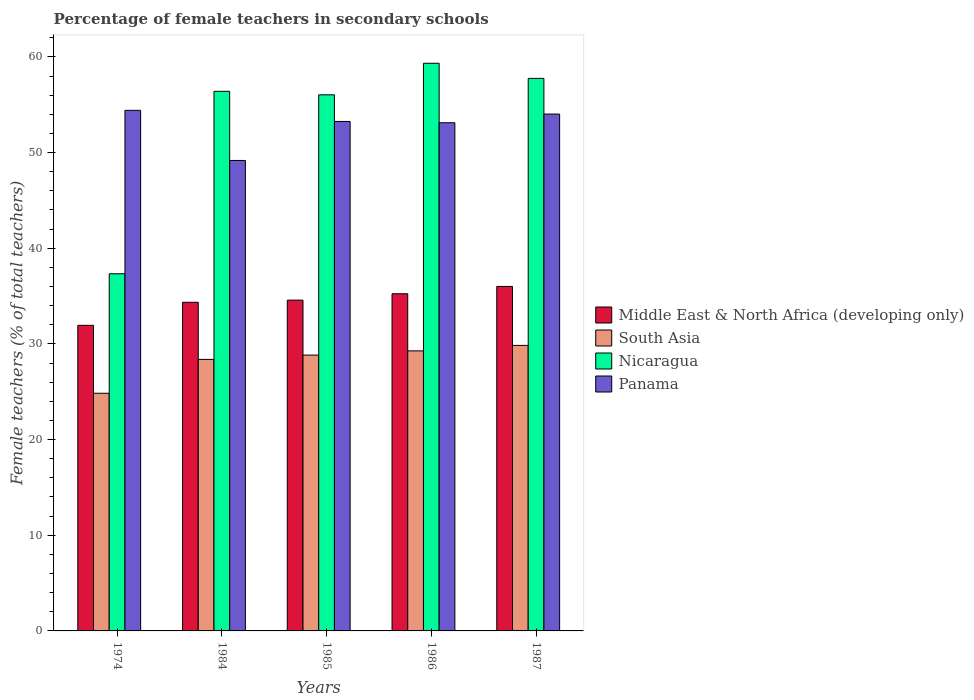How many groups of bars are there?
Provide a short and direct response. 5. Are the number of bars per tick equal to the number of legend labels?
Your answer should be compact. Yes. Are the number of bars on each tick of the X-axis equal?
Your answer should be very brief. Yes. How many bars are there on the 2nd tick from the right?
Your answer should be compact. 4. What is the label of the 1st group of bars from the left?
Provide a short and direct response. 1974. In how many cases, is the number of bars for a given year not equal to the number of legend labels?
Offer a very short reply. 0. What is the percentage of female teachers in Nicaragua in 1984?
Offer a terse response. 56.4. Across all years, what is the maximum percentage of female teachers in South Asia?
Offer a terse response. 29.84. Across all years, what is the minimum percentage of female teachers in Nicaragua?
Provide a succinct answer. 37.33. In which year was the percentage of female teachers in South Asia maximum?
Your response must be concise. 1987. In which year was the percentage of female teachers in Nicaragua minimum?
Provide a succinct answer. 1974. What is the total percentage of female teachers in Panama in the graph?
Offer a terse response. 263.97. What is the difference between the percentage of female teachers in South Asia in 1984 and that in 1986?
Give a very brief answer. -0.89. What is the difference between the percentage of female teachers in South Asia in 1986 and the percentage of female teachers in Middle East & North Africa (developing only) in 1985?
Your answer should be compact. -5.3. What is the average percentage of female teachers in South Asia per year?
Provide a succinct answer. 28.23. In the year 1987, what is the difference between the percentage of female teachers in Panama and percentage of female teachers in Nicaragua?
Give a very brief answer. -3.73. In how many years, is the percentage of female teachers in Panama greater than 44 %?
Your answer should be very brief. 5. What is the ratio of the percentage of female teachers in Nicaragua in 1974 to that in 1985?
Make the answer very short. 0.67. Is the percentage of female teachers in Middle East & North Africa (developing only) in 1974 less than that in 1984?
Make the answer very short. Yes. Is the difference between the percentage of female teachers in Panama in 1985 and 1987 greater than the difference between the percentage of female teachers in Nicaragua in 1985 and 1987?
Your response must be concise. Yes. What is the difference between the highest and the second highest percentage of female teachers in Nicaragua?
Ensure brevity in your answer.  1.58. What is the difference between the highest and the lowest percentage of female teachers in Panama?
Offer a terse response. 5.24. In how many years, is the percentage of female teachers in Panama greater than the average percentage of female teachers in Panama taken over all years?
Ensure brevity in your answer.  4. Is the sum of the percentage of female teachers in Nicaragua in 1974 and 1984 greater than the maximum percentage of female teachers in South Asia across all years?
Offer a very short reply. Yes. What does the 1st bar from the left in 1987 represents?
Your answer should be compact. Middle East & North Africa (developing only). What does the 3rd bar from the right in 1985 represents?
Your answer should be compact. South Asia. How many bars are there?
Your answer should be very brief. 20. Does the graph contain grids?
Provide a short and direct response. No. How many legend labels are there?
Provide a succinct answer. 4. How are the legend labels stacked?
Offer a very short reply. Vertical. What is the title of the graph?
Provide a succinct answer. Percentage of female teachers in secondary schools. Does "Uzbekistan" appear as one of the legend labels in the graph?
Make the answer very short. No. What is the label or title of the X-axis?
Provide a succinct answer. Years. What is the label or title of the Y-axis?
Give a very brief answer. Female teachers (% of total teachers). What is the Female teachers (% of total teachers) in Middle East & North Africa (developing only) in 1974?
Your answer should be compact. 31.94. What is the Female teachers (% of total teachers) in South Asia in 1974?
Keep it short and to the point. 24.84. What is the Female teachers (% of total teachers) of Nicaragua in 1974?
Your response must be concise. 37.33. What is the Female teachers (% of total teachers) in Panama in 1974?
Provide a short and direct response. 54.41. What is the Female teachers (% of total teachers) in Middle East & North Africa (developing only) in 1984?
Your answer should be compact. 34.35. What is the Female teachers (% of total teachers) in South Asia in 1984?
Provide a succinct answer. 28.38. What is the Female teachers (% of total teachers) of Nicaragua in 1984?
Offer a very short reply. 56.4. What is the Female teachers (% of total teachers) in Panama in 1984?
Your answer should be compact. 49.17. What is the Female teachers (% of total teachers) in Middle East & North Africa (developing only) in 1985?
Provide a short and direct response. 34.57. What is the Female teachers (% of total teachers) in South Asia in 1985?
Your answer should be very brief. 28.83. What is the Female teachers (% of total teachers) in Nicaragua in 1985?
Provide a short and direct response. 56.03. What is the Female teachers (% of total teachers) in Panama in 1985?
Your answer should be compact. 53.25. What is the Female teachers (% of total teachers) in Middle East & North Africa (developing only) in 1986?
Offer a very short reply. 35.24. What is the Female teachers (% of total teachers) of South Asia in 1986?
Offer a terse response. 29.27. What is the Female teachers (% of total teachers) in Nicaragua in 1986?
Give a very brief answer. 59.33. What is the Female teachers (% of total teachers) in Panama in 1986?
Your answer should be very brief. 53.11. What is the Female teachers (% of total teachers) in Middle East & North Africa (developing only) in 1987?
Your response must be concise. 36.01. What is the Female teachers (% of total teachers) in South Asia in 1987?
Provide a short and direct response. 29.84. What is the Female teachers (% of total teachers) in Nicaragua in 1987?
Your response must be concise. 57.75. What is the Female teachers (% of total teachers) of Panama in 1987?
Keep it short and to the point. 54.02. Across all years, what is the maximum Female teachers (% of total teachers) in Middle East & North Africa (developing only)?
Your response must be concise. 36.01. Across all years, what is the maximum Female teachers (% of total teachers) of South Asia?
Make the answer very short. 29.84. Across all years, what is the maximum Female teachers (% of total teachers) in Nicaragua?
Make the answer very short. 59.33. Across all years, what is the maximum Female teachers (% of total teachers) of Panama?
Give a very brief answer. 54.41. Across all years, what is the minimum Female teachers (% of total teachers) of Middle East & North Africa (developing only)?
Your response must be concise. 31.94. Across all years, what is the minimum Female teachers (% of total teachers) of South Asia?
Ensure brevity in your answer.  24.84. Across all years, what is the minimum Female teachers (% of total teachers) of Nicaragua?
Ensure brevity in your answer.  37.33. Across all years, what is the minimum Female teachers (% of total teachers) of Panama?
Provide a short and direct response. 49.17. What is the total Female teachers (% of total teachers) of Middle East & North Africa (developing only) in the graph?
Keep it short and to the point. 172.11. What is the total Female teachers (% of total teachers) in South Asia in the graph?
Provide a short and direct response. 141.16. What is the total Female teachers (% of total teachers) in Nicaragua in the graph?
Keep it short and to the point. 266.85. What is the total Female teachers (% of total teachers) of Panama in the graph?
Your answer should be compact. 263.97. What is the difference between the Female teachers (% of total teachers) of Middle East & North Africa (developing only) in 1974 and that in 1984?
Keep it short and to the point. -2.41. What is the difference between the Female teachers (% of total teachers) of South Asia in 1974 and that in 1984?
Make the answer very short. -3.54. What is the difference between the Female teachers (% of total teachers) of Nicaragua in 1974 and that in 1984?
Provide a short and direct response. -19.07. What is the difference between the Female teachers (% of total teachers) in Panama in 1974 and that in 1984?
Your response must be concise. 5.24. What is the difference between the Female teachers (% of total teachers) in Middle East & North Africa (developing only) in 1974 and that in 1985?
Offer a terse response. -2.63. What is the difference between the Female teachers (% of total teachers) in South Asia in 1974 and that in 1985?
Your answer should be compact. -3.99. What is the difference between the Female teachers (% of total teachers) in Nicaragua in 1974 and that in 1985?
Ensure brevity in your answer.  -18.7. What is the difference between the Female teachers (% of total teachers) of Panama in 1974 and that in 1985?
Your answer should be very brief. 1.16. What is the difference between the Female teachers (% of total teachers) in Middle East & North Africa (developing only) in 1974 and that in 1986?
Provide a succinct answer. -3.3. What is the difference between the Female teachers (% of total teachers) in South Asia in 1974 and that in 1986?
Your response must be concise. -4.43. What is the difference between the Female teachers (% of total teachers) in Nicaragua in 1974 and that in 1986?
Provide a succinct answer. -22. What is the difference between the Female teachers (% of total teachers) of Panama in 1974 and that in 1986?
Provide a succinct answer. 1.3. What is the difference between the Female teachers (% of total teachers) in Middle East & North Africa (developing only) in 1974 and that in 1987?
Provide a short and direct response. -4.07. What is the difference between the Female teachers (% of total teachers) of South Asia in 1974 and that in 1987?
Keep it short and to the point. -5. What is the difference between the Female teachers (% of total teachers) of Nicaragua in 1974 and that in 1987?
Give a very brief answer. -20.42. What is the difference between the Female teachers (% of total teachers) of Panama in 1974 and that in 1987?
Make the answer very short. 0.39. What is the difference between the Female teachers (% of total teachers) in Middle East & North Africa (developing only) in 1984 and that in 1985?
Provide a succinct answer. -0.23. What is the difference between the Female teachers (% of total teachers) of South Asia in 1984 and that in 1985?
Ensure brevity in your answer.  -0.45. What is the difference between the Female teachers (% of total teachers) in Nicaragua in 1984 and that in 1985?
Provide a succinct answer. 0.37. What is the difference between the Female teachers (% of total teachers) in Panama in 1984 and that in 1985?
Give a very brief answer. -4.08. What is the difference between the Female teachers (% of total teachers) of Middle East & North Africa (developing only) in 1984 and that in 1986?
Provide a short and direct response. -0.89. What is the difference between the Female teachers (% of total teachers) in South Asia in 1984 and that in 1986?
Your answer should be compact. -0.89. What is the difference between the Female teachers (% of total teachers) of Nicaragua in 1984 and that in 1986?
Ensure brevity in your answer.  -2.93. What is the difference between the Female teachers (% of total teachers) of Panama in 1984 and that in 1986?
Give a very brief answer. -3.94. What is the difference between the Female teachers (% of total teachers) of Middle East & North Africa (developing only) in 1984 and that in 1987?
Provide a short and direct response. -1.66. What is the difference between the Female teachers (% of total teachers) of South Asia in 1984 and that in 1987?
Make the answer very short. -1.46. What is the difference between the Female teachers (% of total teachers) of Nicaragua in 1984 and that in 1987?
Ensure brevity in your answer.  -1.35. What is the difference between the Female teachers (% of total teachers) in Panama in 1984 and that in 1987?
Your response must be concise. -4.85. What is the difference between the Female teachers (% of total teachers) in Middle East & North Africa (developing only) in 1985 and that in 1986?
Offer a terse response. -0.67. What is the difference between the Female teachers (% of total teachers) of South Asia in 1985 and that in 1986?
Give a very brief answer. -0.44. What is the difference between the Female teachers (% of total teachers) in Nicaragua in 1985 and that in 1986?
Offer a very short reply. -3.3. What is the difference between the Female teachers (% of total teachers) of Panama in 1985 and that in 1986?
Offer a very short reply. 0.13. What is the difference between the Female teachers (% of total teachers) in Middle East & North Africa (developing only) in 1985 and that in 1987?
Keep it short and to the point. -1.43. What is the difference between the Female teachers (% of total teachers) of South Asia in 1985 and that in 1987?
Give a very brief answer. -1.01. What is the difference between the Female teachers (% of total teachers) of Nicaragua in 1985 and that in 1987?
Provide a short and direct response. -1.72. What is the difference between the Female teachers (% of total teachers) in Panama in 1985 and that in 1987?
Give a very brief answer. -0.77. What is the difference between the Female teachers (% of total teachers) of Middle East & North Africa (developing only) in 1986 and that in 1987?
Your answer should be very brief. -0.76. What is the difference between the Female teachers (% of total teachers) in South Asia in 1986 and that in 1987?
Your answer should be compact. -0.57. What is the difference between the Female teachers (% of total teachers) in Nicaragua in 1986 and that in 1987?
Keep it short and to the point. 1.58. What is the difference between the Female teachers (% of total teachers) in Panama in 1986 and that in 1987?
Make the answer very short. -0.91. What is the difference between the Female teachers (% of total teachers) of Middle East & North Africa (developing only) in 1974 and the Female teachers (% of total teachers) of South Asia in 1984?
Ensure brevity in your answer.  3.56. What is the difference between the Female teachers (% of total teachers) in Middle East & North Africa (developing only) in 1974 and the Female teachers (% of total teachers) in Nicaragua in 1984?
Give a very brief answer. -24.46. What is the difference between the Female teachers (% of total teachers) of Middle East & North Africa (developing only) in 1974 and the Female teachers (% of total teachers) of Panama in 1984?
Give a very brief answer. -17.23. What is the difference between the Female teachers (% of total teachers) of South Asia in 1974 and the Female teachers (% of total teachers) of Nicaragua in 1984?
Your answer should be very brief. -31.56. What is the difference between the Female teachers (% of total teachers) in South Asia in 1974 and the Female teachers (% of total teachers) in Panama in 1984?
Give a very brief answer. -24.33. What is the difference between the Female teachers (% of total teachers) in Nicaragua in 1974 and the Female teachers (% of total teachers) in Panama in 1984?
Make the answer very short. -11.84. What is the difference between the Female teachers (% of total teachers) of Middle East & North Africa (developing only) in 1974 and the Female teachers (% of total teachers) of South Asia in 1985?
Your response must be concise. 3.11. What is the difference between the Female teachers (% of total teachers) in Middle East & North Africa (developing only) in 1974 and the Female teachers (% of total teachers) in Nicaragua in 1985?
Give a very brief answer. -24.09. What is the difference between the Female teachers (% of total teachers) in Middle East & North Africa (developing only) in 1974 and the Female teachers (% of total teachers) in Panama in 1985?
Make the answer very short. -21.31. What is the difference between the Female teachers (% of total teachers) of South Asia in 1974 and the Female teachers (% of total teachers) of Nicaragua in 1985?
Your response must be concise. -31.19. What is the difference between the Female teachers (% of total teachers) in South Asia in 1974 and the Female teachers (% of total teachers) in Panama in 1985?
Your response must be concise. -28.41. What is the difference between the Female teachers (% of total teachers) in Nicaragua in 1974 and the Female teachers (% of total teachers) in Panama in 1985?
Provide a short and direct response. -15.92. What is the difference between the Female teachers (% of total teachers) in Middle East & North Africa (developing only) in 1974 and the Female teachers (% of total teachers) in South Asia in 1986?
Give a very brief answer. 2.67. What is the difference between the Female teachers (% of total teachers) in Middle East & North Africa (developing only) in 1974 and the Female teachers (% of total teachers) in Nicaragua in 1986?
Provide a short and direct response. -27.39. What is the difference between the Female teachers (% of total teachers) of Middle East & North Africa (developing only) in 1974 and the Female teachers (% of total teachers) of Panama in 1986?
Make the answer very short. -21.17. What is the difference between the Female teachers (% of total teachers) of South Asia in 1974 and the Female teachers (% of total teachers) of Nicaragua in 1986?
Keep it short and to the point. -34.49. What is the difference between the Female teachers (% of total teachers) of South Asia in 1974 and the Female teachers (% of total teachers) of Panama in 1986?
Offer a terse response. -28.27. What is the difference between the Female teachers (% of total teachers) of Nicaragua in 1974 and the Female teachers (% of total teachers) of Panama in 1986?
Your answer should be very brief. -15.78. What is the difference between the Female teachers (% of total teachers) of Middle East & North Africa (developing only) in 1974 and the Female teachers (% of total teachers) of South Asia in 1987?
Offer a terse response. 2.1. What is the difference between the Female teachers (% of total teachers) of Middle East & North Africa (developing only) in 1974 and the Female teachers (% of total teachers) of Nicaragua in 1987?
Offer a terse response. -25.81. What is the difference between the Female teachers (% of total teachers) in Middle East & North Africa (developing only) in 1974 and the Female teachers (% of total teachers) in Panama in 1987?
Offer a very short reply. -22.08. What is the difference between the Female teachers (% of total teachers) in South Asia in 1974 and the Female teachers (% of total teachers) in Nicaragua in 1987?
Provide a short and direct response. -32.91. What is the difference between the Female teachers (% of total teachers) in South Asia in 1974 and the Female teachers (% of total teachers) in Panama in 1987?
Your answer should be compact. -29.18. What is the difference between the Female teachers (% of total teachers) in Nicaragua in 1974 and the Female teachers (% of total teachers) in Panama in 1987?
Your answer should be very brief. -16.69. What is the difference between the Female teachers (% of total teachers) in Middle East & North Africa (developing only) in 1984 and the Female teachers (% of total teachers) in South Asia in 1985?
Make the answer very short. 5.52. What is the difference between the Female teachers (% of total teachers) of Middle East & North Africa (developing only) in 1984 and the Female teachers (% of total teachers) of Nicaragua in 1985?
Keep it short and to the point. -21.69. What is the difference between the Female teachers (% of total teachers) in Middle East & North Africa (developing only) in 1984 and the Female teachers (% of total teachers) in Panama in 1985?
Offer a very short reply. -18.9. What is the difference between the Female teachers (% of total teachers) of South Asia in 1984 and the Female teachers (% of total teachers) of Nicaragua in 1985?
Keep it short and to the point. -27.65. What is the difference between the Female teachers (% of total teachers) in South Asia in 1984 and the Female teachers (% of total teachers) in Panama in 1985?
Provide a succinct answer. -24.87. What is the difference between the Female teachers (% of total teachers) in Nicaragua in 1984 and the Female teachers (% of total teachers) in Panama in 1985?
Make the answer very short. 3.15. What is the difference between the Female teachers (% of total teachers) of Middle East & North Africa (developing only) in 1984 and the Female teachers (% of total teachers) of South Asia in 1986?
Provide a short and direct response. 5.08. What is the difference between the Female teachers (% of total teachers) in Middle East & North Africa (developing only) in 1984 and the Female teachers (% of total teachers) in Nicaragua in 1986?
Ensure brevity in your answer.  -24.98. What is the difference between the Female teachers (% of total teachers) in Middle East & North Africa (developing only) in 1984 and the Female teachers (% of total teachers) in Panama in 1986?
Offer a very short reply. -18.77. What is the difference between the Female teachers (% of total teachers) of South Asia in 1984 and the Female teachers (% of total teachers) of Nicaragua in 1986?
Your answer should be very brief. -30.95. What is the difference between the Female teachers (% of total teachers) of South Asia in 1984 and the Female teachers (% of total teachers) of Panama in 1986?
Your answer should be very brief. -24.74. What is the difference between the Female teachers (% of total teachers) of Nicaragua in 1984 and the Female teachers (% of total teachers) of Panama in 1986?
Your answer should be very brief. 3.29. What is the difference between the Female teachers (% of total teachers) of Middle East & North Africa (developing only) in 1984 and the Female teachers (% of total teachers) of South Asia in 1987?
Ensure brevity in your answer.  4.51. What is the difference between the Female teachers (% of total teachers) of Middle East & North Africa (developing only) in 1984 and the Female teachers (% of total teachers) of Nicaragua in 1987?
Offer a very short reply. -23.4. What is the difference between the Female teachers (% of total teachers) of Middle East & North Africa (developing only) in 1984 and the Female teachers (% of total teachers) of Panama in 1987?
Your answer should be very brief. -19.67. What is the difference between the Female teachers (% of total teachers) of South Asia in 1984 and the Female teachers (% of total teachers) of Nicaragua in 1987?
Offer a terse response. -29.37. What is the difference between the Female teachers (% of total teachers) of South Asia in 1984 and the Female teachers (% of total teachers) of Panama in 1987?
Your answer should be compact. -25.64. What is the difference between the Female teachers (% of total teachers) of Nicaragua in 1984 and the Female teachers (% of total teachers) of Panama in 1987?
Provide a succinct answer. 2.38. What is the difference between the Female teachers (% of total teachers) of Middle East & North Africa (developing only) in 1985 and the Female teachers (% of total teachers) of South Asia in 1986?
Your answer should be compact. 5.3. What is the difference between the Female teachers (% of total teachers) in Middle East & North Africa (developing only) in 1985 and the Female teachers (% of total teachers) in Nicaragua in 1986?
Offer a terse response. -24.76. What is the difference between the Female teachers (% of total teachers) in Middle East & North Africa (developing only) in 1985 and the Female teachers (% of total teachers) in Panama in 1986?
Your answer should be very brief. -18.54. What is the difference between the Female teachers (% of total teachers) in South Asia in 1985 and the Female teachers (% of total teachers) in Nicaragua in 1986?
Your answer should be compact. -30.5. What is the difference between the Female teachers (% of total teachers) in South Asia in 1985 and the Female teachers (% of total teachers) in Panama in 1986?
Offer a very short reply. -24.28. What is the difference between the Female teachers (% of total teachers) of Nicaragua in 1985 and the Female teachers (% of total teachers) of Panama in 1986?
Your answer should be very brief. 2.92. What is the difference between the Female teachers (% of total teachers) in Middle East & North Africa (developing only) in 1985 and the Female teachers (% of total teachers) in South Asia in 1987?
Your answer should be very brief. 4.73. What is the difference between the Female teachers (% of total teachers) of Middle East & North Africa (developing only) in 1985 and the Female teachers (% of total teachers) of Nicaragua in 1987?
Provide a short and direct response. -23.18. What is the difference between the Female teachers (% of total teachers) in Middle East & North Africa (developing only) in 1985 and the Female teachers (% of total teachers) in Panama in 1987?
Offer a very short reply. -19.45. What is the difference between the Female teachers (% of total teachers) in South Asia in 1985 and the Female teachers (% of total teachers) in Nicaragua in 1987?
Give a very brief answer. -28.92. What is the difference between the Female teachers (% of total teachers) in South Asia in 1985 and the Female teachers (% of total teachers) in Panama in 1987?
Give a very brief answer. -25.19. What is the difference between the Female teachers (% of total teachers) of Nicaragua in 1985 and the Female teachers (% of total teachers) of Panama in 1987?
Offer a very short reply. 2.01. What is the difference between the Female teachers (% of total teachers) in Middle East & North Africa (developing only) in 1986 and the Female teachers (% of total teachers) in South Asia in 1987?
Provide a short and direct response. 5.4. What is the difference between the Female teachers (% of total teachers) in Middle East & North Africa (developing only) in 1986 and the Female teachers (% of total teachers) in Nicaragua in 1987?
Give a very brief answer. -22.51. What is the difference between the Female teachers (% of total teachers) in Middle East & North Africa (developing only) in 1986 and the Female teachers (% of total teachers) in Panama in 1987?
Offer a very short reply. -18.78. What is the difference between the Female teachers (% of total teachers) of South Asia in 1986 and the Female teachers (% of total teachers) of Nicaragua in 1987?
Keep it short and to the point. -28.48. What is the difference between the Female teachers (% of total teachers) of South Asia in 1986 and the Female teachers (% of total teachers) of Panama in 1987?
Make the answer very short. -24.75. What is the difference between the Female teachers (% of total teachers) of Nicaragua in 1986 and the Female teachers (% of total teachers) of Panama in 1987?
Keep it short and to the point. 5.31. What is the average Female teachers (% of total teachers) in Middle East & North Africa (developing only) per year?
Your answer should be compact. 34.42. What is the average Female teachers (% of total teachers) of South Asia per year?
Your answer should be compact. 28.23. What is the average Female teachers (% of total teachers) of Nicaragua per year?
Offer a terse response. 53.37. What is the average Female teachers (% of total teachers) of Panama per year?
Your response must be concise. 52.79. In the year 1974, what is the difference between the Female teachers (% of total teachers) of Middle East & North Africa (developing only) and Female teachers (% of total teachers) of South Asia?
Make the answer very short. 7.1. In the year 1974, what is the difference between the Female teachers (% of total teachers) of Middle East & North Africa (developing only) and Female teachers (% of total teachers) of Nicaragua?
Ensure brevity in your answer.  -5.39. In the year 1974, what is the difference between the Female teachers (% of total teachers) in Middle East & North Africa (developing only) and Female teachers (% of total teachers) in Panama?
Make the answer very short. -22.47. In the year 1974, what is the difference between the Female teachers (% of total teachers) in South Asia and Female teachers (% of total teachers) in Nicaragua?
Give a very brief answer. -12.49. In the year 1974, what is the difference between the Female teachers (% of total teachers) of South Asia and Female teachers (% of total teachers) of Panama?
Your answer should be compact. -29.57. In the year 1974, what is the difference between the Female teachers (% of total teachers) of Nicaragua and Female teachers (% of total teachers) of Panama?
Give a very brief answer. -17.08. In the year 1984, what is the difference between the Female teachers (% of total teachers) of Middle East & North Africa (developing only) and Female teachers (% of total teachers) of South Asia?
Offer a terse response. 5.97. In the year 1984, what is the difference between the Female teachers (% of total teachers) in Middle East & North Africa (developing only) and Female teachers (% of total teachers) in Nicaragua?
Offer a very short reply. -22.05. In the year 1984, what is the difference between the Female teachers (% of total teachers) of Middle East & North Africa (developing only) and Female teachers (% of total teachers) of Panama?
Offer a very short reply. -14.82. In the year 1984, what is the difference between the Female teachers (% of total teachers) of South Asia and Female teachers (% of total teachers) of Nicaragua?
Keep it short and to the point. -28.02. In the year 1984, what is the difference between the Female teachers (% of total teachers) in South Asia and Female teachers (% of total teachers) in Panama?
Ensure brevity in your answer.  -20.79. In the year 1984, what is the difference between the Female teachers (% of total teachers) of Nicaragua and Female teachers (% of total teachers) of Panama?
Ensure brevity in your answer.  7.23. In the year 1985, what is the difference between the Female teachers (% of total teachers) in Middle East & North Africa (developing only) and Female teachers (% of total teachers) in South Asia?
Provide a short and direct response. 5.74. In the year 1985, what is the difference between the Female teachers (% of total teachers) of Middle East & North Africa (developing only) and Female teachers (% of total teachers) of Nicaragua?
Make the answer very short. -21.46. In the year 1985, what is the difference between the Female teachers (% of total teachers) of Middle East & North Africa (developing only) and Female teachers (% of total teachers) of Panama?
Offer a terse response. -18.67. In the year 1985, what is the difference between the Female teachers (% of total teachers) of South Asia and Female teachers (% of total teachers) of Nicaragua?
Give a very brief answer. -27.2. In the year 1985, what is the difference between the Female teachers (% of total teachers) of South Asia and Female teachers (% of total teachers) of Panama?
Ensure brevity in your answer.  -24.42. In the year 1985, what is the difference between the Female teachers (% of total teachers) of Nicaragua and Female teachers (% of total teachers) of Panama?
Offer a very short reply. 2.79. In the year 1986, what is the difference between the Female teachers (% of total teachers) of Middle East & North Africa (developing only) and Female teachers (% of total teachers) of South Asia?
Your answer should be compact. 5.97. In the year 1986, what is the difference between the Female teachers (% of total teachers) in Middle East & North Africa (developing only) and Female teachers (% of total teachers) in Nicaragua?
Your answer should be very brief. -24.09. In the year 1986, what is the difference between the Female teachers (% of total teachers) of Middle East & North Africa (developing only) and Female teachers (% of total teachers) of Panama?
Provide a succinct answer. -17.87. In the year 1986, what is the difference between the Female teachers (% of total teachers) in South Asia and Female teachers (% of total teachers) in Nicaragua?
Give a very brief answer. -30.06. In the year 1986, what is the difference between the Female teachers (% of total teachers) in South Asia and Female teachers (% of total teachers) in Panama?
Offer a very short reply. -23.84. In the year 1986, what is the difference between the Female teachers (% of total teachers) in Nicaragua and Female teachers (% of total teachers) in Panama?
Provide a short and direct response. 6.22. In the year 1987, what is the difference between the Female teachers (% of total teachers) in Middle East & North Africa (developing only) and Female teachers (% of total teachers) in South Asia?
Ensure brevity in your answer.  6.16. In the year 1987, what is the difference between the Female teachers (% of total teachers) in Middle East & North Africa (developing only) and Female teachers (% of total teachers) in Nicaragua?
Offer a very short reply. -21.75. In the year 1987, what is the difference between the Female teachers (% of total teachers) of Middle East & North Africa (developing only) and Female teachers (% of total teachers) of Panama?
Keep it short and to the point. -18.02. In the year 1987, what is the difference between the Female teachers (% of total teachers) in South Asia and Female teachers (% of total teachers) in Nicaragua?
Your answer should be very brief. -27.91. In the year 1987, what is the difference between the Female teachers (% of total teachers) of South Asia and Female teachers (% of total teachers) of Panama?
Offer a very short reply. -24.18. In the year 1987, what is the difference between the Female teachers (% of total teachers) of Nicaragua and Female teachers (% of total teachers) of Panama?
Your answer should be very brief. 3.73. What is the ratio of the Female teachers (% of total teachers) of Middle East & North Africa (developing only) in 1974 to that in 1984?
Provide a short and direct response. 0.93. What is the ratio of the Female teachers (% of total teachers) in South Asia in 1974 to that in 1984?
Offer a terse response. 0.88. What is the ratio of the Female teachers (% of total teachers) in Nicaragua in 1974 to that in 1984?
Keep it short and to the point. 0.66. What is the ratio of the Female teachers (% of total teachers) of Panama in 1974 to that in 1984?
Make the answer very short. 1.11. What is the ratio of the Female teachers (% of total teachers) in Middle East & North Africa (developing only) in 1974 to that in 1985?
Your answer should be compact. 0.92. What is the ratio of the Female teachers (% of total teachers) of South Asia in 1974 to that in 1985?
Give a very brief answer. 0.86. What is the ratio of the Female teachers (% of total teachers) of Nicaragua in 1974 to that in 1985?
Your answer should be compact. 0.67. What is the ratio of the Female teachers (% of total teachers) of Panama in 1974 to that in 1985?
Offer a terse response. 1.02. What is the ratio of the Female teachers (% of total teachers) in Middle East & North Africa (developing only) in 1974 to that in 1986?
Your answer should be compact. 0.91. What is the ratio of the Female teachers (% of total teachers) of South Asia in 1974 to that in 1986?
Provide a short and direct response. 0.85. What is the ratio of the Female teachers (% of total teachers) in Nicaragua in 1974 to that in 1986?
Offer a very short reply. 0.63. What is the ratio of the Female teachers (% of total teachers) of Panama in 1974 to that in 1986?
Your answer should be compact. 1.02. What is the ratio of the Female teachers (% of total teachers) of Middle East & North Africa (developing only) in 1974 to that in 1987?
Offer a terse response. 0.89. What is the ratio of the Female teachers (% of total teachers) of South Asia in 1974 to that in 1987?
Make the answer very short. 0.83. What is the ratio of the Female teachers (% of total teachers) in Nicaragua in 1974 to that in 1987?
Offer a terse response. 0.65. What is the ratio of the Female teachers (% of total teachers) in Panama in 1974 to that in 1987?
Ensure brevity in your answer.  1.01. What is the ratio of the Female teachers (% of total teachers) of South Asia in 1984 to that in 1985?
Make the answer very short. 0.98. What is the ratio of the Female teachers (% of total teachers) of Nicaragua in 1984 to that in 1985?
Provide a succinct answer. 1.01. What is the ratio of the Female teachers (% of total teachers) of Panama in 1984 to that in 1985?
Provide a short and direct response. 0.92. What is the ratio of the Female teachers (% of total teachers) of Middle East & North Africa (developing only) in 1984 to that in 1986?
Ensure brevity in your answer.  0.97. What is the ratio of the Female teachers (% of total teachers) in South Asia in 1984 to that in 1986?
Provide a short and direct response. 0.97. What is the ratio of the Female teachers (% of total teachers) of Nicaragua in 1984 to that in 1986?
Your answer should be very brief. 0.95. What is the ratio of the Female teachers (% of total teachers) of Panama in 1984 to that in 1986?
Offer a terse response. 0.93. What is the ratio of the Female teachers (% of total teachers) of Middle East & North Africa (developing only) in 1984 to that in 1987?
Offer a terse response. 0.95. What is the ratio of the Female teachers (% of total teachers) in South Asia in 1984 to that in 1987?
Give a very brief answer. 0.95. What is the ratio of the Female teachers (% of total teachers) in Nicaragua in 1984 to that in 1987?
Provide a succinct answer. 0.98. What is the ratio of the Female teachers (% of total teachers) in Panama in 1984 to that in 1987?
Give a very brief answer. 0.91. What is the ratio of the Female teachers (% of total teachers) in Middle East & North Africa (developing only) in 1985 to that in 1986?
Provide a succinct answer. 0.98. What is the ratio of the Female teachers (% of total teachers) of South Asia in 1985 to that in 1986?
Make the answer very short. 0.98. What is the ratio of the Female teachers (% of total teachers) of Panama in 1985 to that in 1986?
Ensure brevity in your answer.  1. What is the ratio of the Female teachers (% of total teachers) in Middle East & North Africa (developing only) in 1985 to that in 1987?
Your response must be concise. 0.96. What is the ratio of the Female teachers (% of total teachers) of South Asia in 1985 to that in 1987?
Provide a succinct answer. 0.97. What is the ratio of the Female teachers (% of total teachers) of Nicaragua in 1985 to that in 1987?
Offer a terse response. 0.97. What is the ratio of the Female teachers (% of total teachers) in Panama in 1985 to that in 1987?
Offer a very short reply. 0.99. What is the ratio of the Female teachers (% of total teachers) of Middle East & North Africa (developing only) in 1986 to that in 1987?
Your response must be concise. 0.98. What is the ratio of the Female teachers (% of total teachers) in South Asia in 1986 to that in 1987?
Your response must be concise. 0.98. What is the ratio of the Female teachers (% of total teachers) of Nicaragua in 1986 to that in 1987?
Offer a terse response. 1.03. What is the ratio of the Female teachers (% of total teachers) in Panama in 1986 to that in 1987?
Provide a short and direct response. 0.98. What is the difference between the highest and the second highest Female teachers (% of total teachers) of Middle East & North Africa (developing only)?
Your response must be concise. 0.76. What is the difference between the highest and the second highest Female teachers (% of total teachers) of South Asia?
Your answer should be very brief. 0.57. What is the difference between the highest and the second highest Female teachers (% of total teachers) in Nicaragua?
Keep it short and to the point. 1.58. What is the difference between the highest and the second highest Female teachers (% of total teachers) of Panama?
Offer a terse response. 0.39. What is the difference between the highest and the lowest Female teachers (% of total teachers) of Middle East & North Africa (developing only)?
Ensure brevity in your answer.  4.07. What is the difference between the highest and the lowest Female teachers (% of total teachers) in South Asia?
Keep it short and to the point. 5. What is the difference between the highest and the lowest Female teachers (% of total teachers) in Nicaragua?
Provide a succinct answer. 22. What is the difference between the highest and the lowest Female teachers (% of total teachers) in Panama?
Offer a terse response. 5.24. 